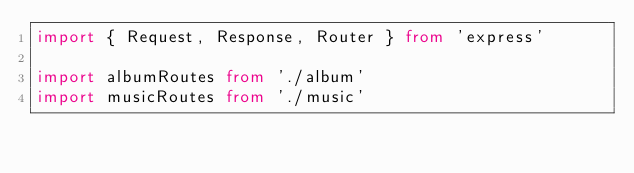<code> <loc_0><loc_0><loc_500><loc_500><_TypeScript_>import { Request, Response, Router } from 'express'

import albumRoutes from './album'
import musicRoutes from './music'</code> 